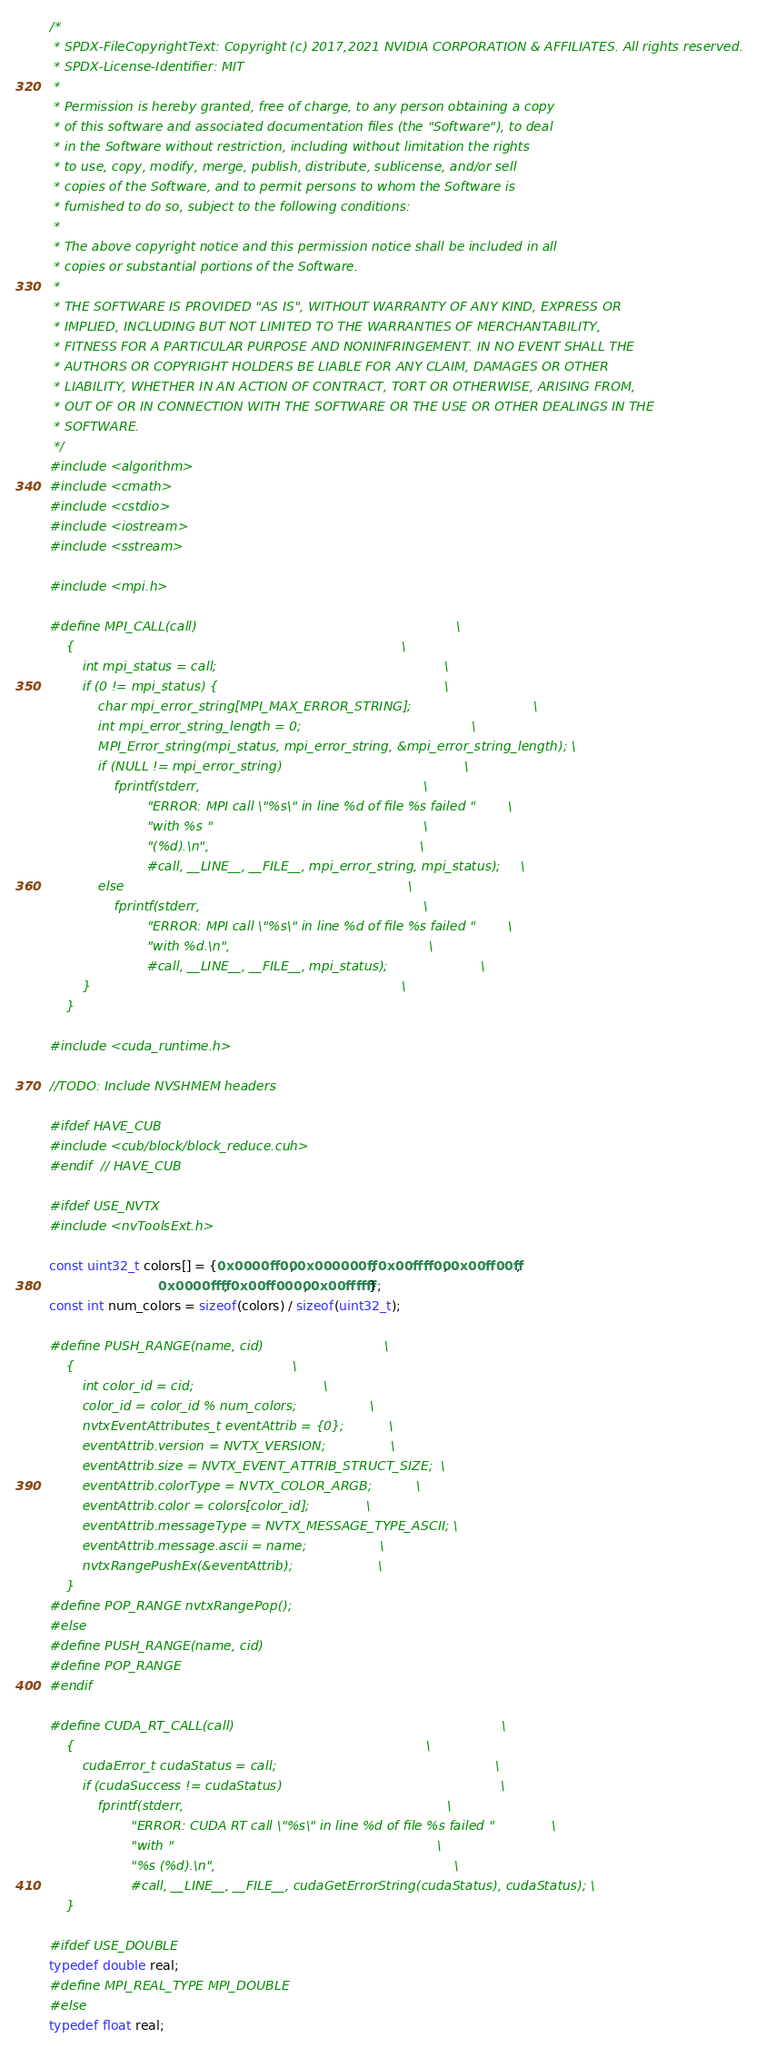Convert code to text. <code><loc_0><loc_0><loc_500><loc_500><_Cuda_>/* 
 * SPDX-FileCopyrightText: Copyright (c) 2017,2021 NVIDIA CORPORATION & AFFILIATES. All rights reserved.
 * SPDX-License-Identifier: MIT
 * 
 * Permission is hereby granted, free of charge, to any person obtaining a copy
 * of this software and associated documentation files (the "Software"), to deal
 * in the Software without restriction, including without limitation the rights
 * to use, copy, modify, merge, publish, distribute, sublicense, and/or sell
 * copies of the Software, and to permit persons to whom the Software is
 * furnished to do so, subject to the following conditions:
 * 
 * The above copyright notice and this permission notice shall be included in all
 * copies or substantial portions of the Software.
 * 
 * THE SOFTWARE IS PROVIDED "AS IS", WITHOUT WARRANTY OF ANY KIND, EXPRESS OR
 * IMPLIED, INCLUDING BUT NOT LIMITED TO THE WARRANTIES OF MERCHANTABILITY,
 * FITNESS FOR A PARTICULAR PURPOSE AND NONINFRINGEMENT. IN NO EVENT SHALL THE
 * AUTHORS OR COPYRIGHT HOLDERS BE LIABLE FOR ANY CLAIM, DAMAGES OR OTHER
 * LIABILITY, WHETHER IN AN ACTION OF CONTRACT, TORT OR OTHERWISE, ARISING FROM,
 * OUT OF OR IN CONNECTION WITH THE SOFTWARE OR THE USE OR OTHER DEALINGS IN THE
 * SOFTWARE.
 */
#include <algorithm>
#include <cmath>
#include <cstdio>
#include <iostream>
#include <sstream>

#include <mpi.h>

#define MPI_CALL(call)                                                                \
    {                                                                                 \
        int mpi_status = call;                                                        \
        if (0 != mpi_status) {                                                        \
            char mpi_error_string[MPI_MAX_ERROR_STRING];                              \
            int mpi_error_string_length = 0;                                          \
            MPI_Error_string(mpi_status, mpi_error_string, &mpi_error_string_length); \
            if (NULL != mpi_error_string)                                             \
                fprintf(stderr,                                                       \
                        "ERROR: MPI call \"%s\" in line %d of file %s failed "        \
                        "with %s "                                                    \
                        "(%d).\n",                                                    \
                        #call, __LINE__, __FILE__, mpi_error_string, mpi_status);     \
            else                                                                      \
                fprintf(stderr,                                                       \
                        "ERROR: MPI call \"%s\" in line %d of file %s failed "        \
                        "with %d.\n",                                                 \
                        #call, __LINE__, __FILE__, mpi_status);                       \
        }                                                                             \
    }

#include <cuda_runtime.h>

//TODO: Include NVSHMEM headers

#ifdef HAVE_CUB
#include <cub/block/block_reduce.cuh>
#endif  // HAVE_CUB

#ifdef USE_NVTX
#include <nvToolsExt.h>

const uint32_t colors[] = {0x0000ff00, 0x000000ff, 0x00ffff00, 0x00ff00ff,
                           0x0000ffff, 0x00ff0000, 0x00ffffff};
const int num_colors = sizeof(colors) / sizeof(uint32_t);

#define PUSH_RANGE(name, cid)                              \
    {                                                      \
        int color_id = cid;                                \
        color_id = color_id % num_colors;                  \
        nvtxEventAttributes_t eventAttrib = {0};           \
        eventAttrib.version = NVTX_VERSION;                \
        eventAttrib.size = NVTX_EVENT_ATTRIB_STRUCT_SIZE;  \
        eventAttrib.colorType = NVTX_COLOR_ARGB;           \
        eventAttrib.color = colors[color_id];              \
        eventAttrib.messageType = NVTX_MESSAGE_TYPE_ASCII; \
        eventAttrib.message.ascii = name;                  \
        nvtxRangePushEx(&eventAttrib);                     \
    }
#define POP_RANGE nvtxRangePop();
#else
#define PUSH_RANGE(name, cid)
#define POP_RANGE
#endif

#define CUDA_RT_CALL(call)                                                                  \
    {                                                                                       \
        cudaError_t cudaStatus = call;                                                      \
        if (cudaSuccess != cudaStatus)                                                      \
            fprintf(stderr,                                                                 \
                    "ERROR: CUDA RT call \"%s\" in line %d of file %s failed "              \
                    "with "                                                                 \
                    "%s (%d).\n",                                                           \
                    #call, __LINE__, __FILE__, cudaGetErrorString(cudaStatus), cudaStatus); \
    }

#ifdef USE_DOUBLE
typedef double real;
#define MPI_REAL_TYPE MPI_DOUBLE
#else
typedef float real;</code> 